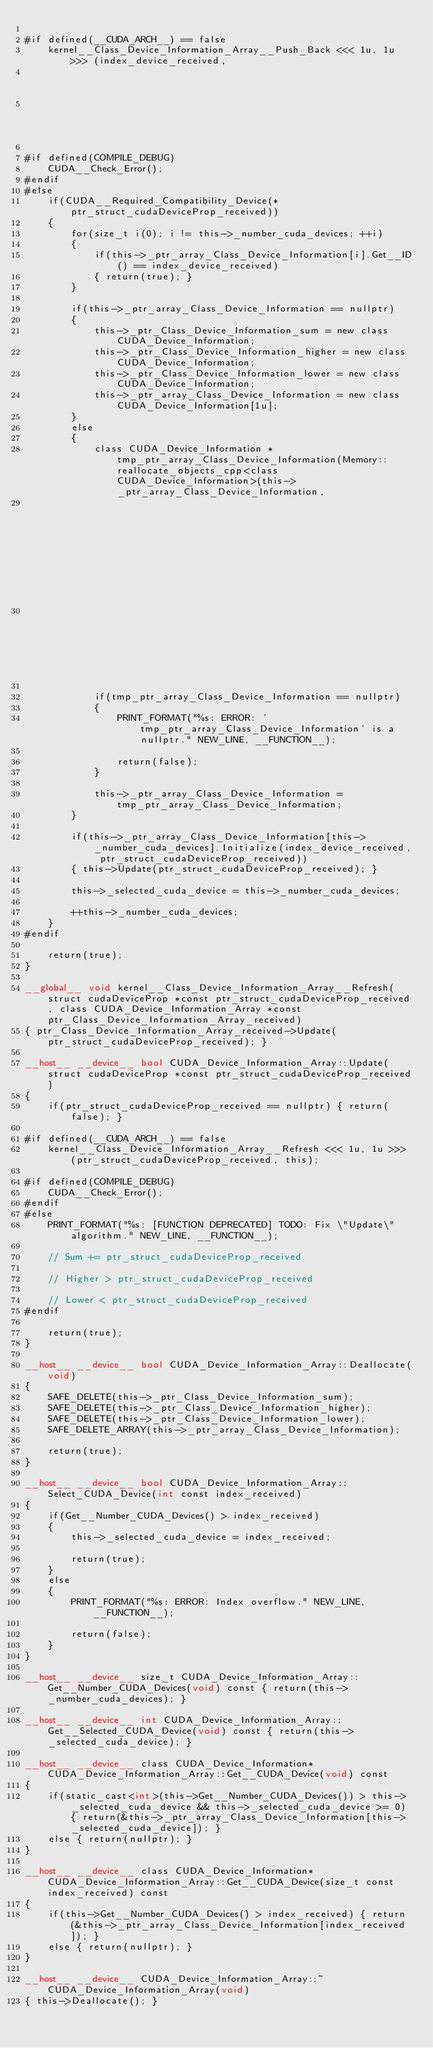Convert code to text. <code><loc_0><loc_0><loc_500><loc_500><_Cuda_>
#if defined(__CUDA_ARCH__) == false
    kernel__Class_Device_Information_Array__Push_Back <<< 1u, 1u >>> (index_device_received,
                                                                                                             ptr_struct_cudaDeviceProp_received,
                                                                                                             this);
        
#if defined(COMPILE_DEBUG)
    CUDA__Check_Error();
#endif
#else
    if(CUDA__Required_Compatibility_Device(*ptr_struct_cudaDeviceProp_received))
    {
        for(size_t i(0); i != this->_number_cuda_devices; ++i)
        {
            if(this->_ptr_array_Class_Device_Information[i].Get__ID() == index_device_received)
            { return(true); }
        }

        if(this->_ptr_array_Class_Device_Information == nullptr)
        {
            this->_ptr_Class_Device_Information_sum = new class CUDA_Device_Information;
            this->_ptr_Class_Device_Information_higher = new class CUDA_Device_Information;
            this->_ptr_Class_Device_Information_lower = new class CUDA_Device_Information;
            this->_ptr_array_Class_Device_Information = new class CUDA_Device_Information[1u];
        }
        else
        {
            class CUDA_Device_Information *tmp_ptr_array_Class_Device_Information(Memory::reallocate_objects_cpp<class CUDA_Device_Information>(this->_ptr_array_Class_Device_Information,
                                                                                                                                                                                                                           this->_number_cuda_devices + 1u,
                                                                                                                                                                                                                           this->_number_cuda_devices));

            if(tmp_ptr_array_Class_Device_Information == nullptr)
            {
                PRINT_FORMAT("%s: ERROR: 'tmp_ptr_array_Class_Device_Information' is a nullptr." NEW_LINE, __FUNCTION__);

                return(false);
            }

            this->_ptr_array_Class_Device_Information = tmp_ptr_array_Class_Device_Information;
        }

        if(this->_ptr_array_Class_Device_Information[this->_number_cuda_devices].Initialize(index_device_received, ptr_struct_cudaDeviceProp_received))
        { this->Update(ptr_struct_cudaDeviceProp_received); }

        this->_selected_cuda_device = this->_number_cuda_devices;

        ++this->_number_cuda_devices;
    }
#endif

    return(true);
}

__global__ void kernel__Class_Device_Information_Array__Refresh(struct cudaDeviceProp *const ptr_struct_cudaDeviceProp_received, class CUDA_Device_Information_Array *const ptr_Class_Device_Information_Array_received)
{ ptr_Class_Device_Information_Array_received->Update(ptr_struct_cudaDeviceProp_received); }

__host__ __device__ bool CUDA_Device_Information_Array::Update(struct cudaDeviceProp *const ptr_struct_cudaDeviceProp_received)
{
    if(ptr_struct_cudaDeviceProp_received == nullptr) { return(false); }

#if defined(__CUDA_ARCH__) == false
    kernel__Class_Device_Information_Array__Refresh <<< 1u, 1u >>> (ptr_struct_cudaDeviceProp_received, this);
        
#if defined(COMPILE_DEBUG)
    CUDA__Check_Error();
#endif
#else
    PRINT_FORMAT("%s: [FUNCTION DEPRECATED] TODO: Fix \"Update\" algorithm." NEW_LINE, __FUNCTION__);

    // Sum += ptr_struct_cudaDeviceProp_received

    // Higher > ptr_struct_cudaDeviceProp_received

    // Lower < ptr_struct_cudaDeviceProp_received
#endif

    return(true);
}

__host__ __device__ bool CUDA_Device_Information_Array::Deallocate(void)
{
    SAFE_DELETE(this->_ptr_Class_Device_Information_sum);
    SAFE_DELETE(this->_ptr_Class_Device_Information_higher);
    SAFE_DELETE(this->_ptr_Class_Device_Information_lower);
    SAFE_DELETE_ARRAY(this->_ptr_array_Class_Device_Information);

    return(true);
}

__host__ __device__ bool CUDA_Device_Information_Array::Select_CUDA_Device(int const index_received)
{
    if(Get__Number_CUDA_Devices() > index_received)
    {
        this->_selected_cuda_device = index_received;

        return(true);
    }
    else
    {
        PRINT_FORMAT("%s: ERROR: Index overflow." NEW_LINE, __FUNCTION__);
            
        return(false);
    }
}

__host__ __device__ size_t CUDA_Device_Information_Array::Get__Number_CUDA_Devices(void) const { return(this->_number_cuda_devices); }

__host__ __device__ int CUDA_Device_Information_Array::Get__Selected_CUDA_Device(void) const { return(this->_selected_cuda_device); }

__host__ __device__ class CUDA_Device_Information* CUDA_Device_Information_Array::Get__CUDA_Device(void) const
{
    if(static_cast<int>(this->Get__Number_CUDA_Devices()) > this->_selected_cuda_device && this->_selected_cuda_device >= 0) { return(&this->_ptr_array_Class_Device_Information[this->_selected_cuda_device]); }
    else { return(nullptr); }
}

__host__ __device__ class CUDA_Device_Information* CUDA_Device_Information_Array::Get__CUDA_Device(size_t const index_received) const
{
    if(this->Get__Number_CUDA_Devices() > index_received) { return(&this->_ptr_array_Class_Device_Information[index_received]); }
    else { return(nullptr); }
}

__host__ __device__ CUDA_Device_Information_Array::~CUDA_Device_Information_Array(void)
{ this->Deallocate(); }
</code> 